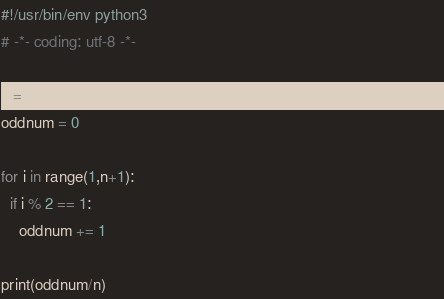Convert code to text. <code><loc_0><loc_0><loc_500><loc_500><_Python_>#!/usr/bin/env python3
# -*- coding: utf-8 -*-                                                                      

n = int(input())
oddnum = 0 

for i in range(1,n+1):
  if i % 2 == 1:
    oddnum += 1

print(oddnum/n)
</code> 